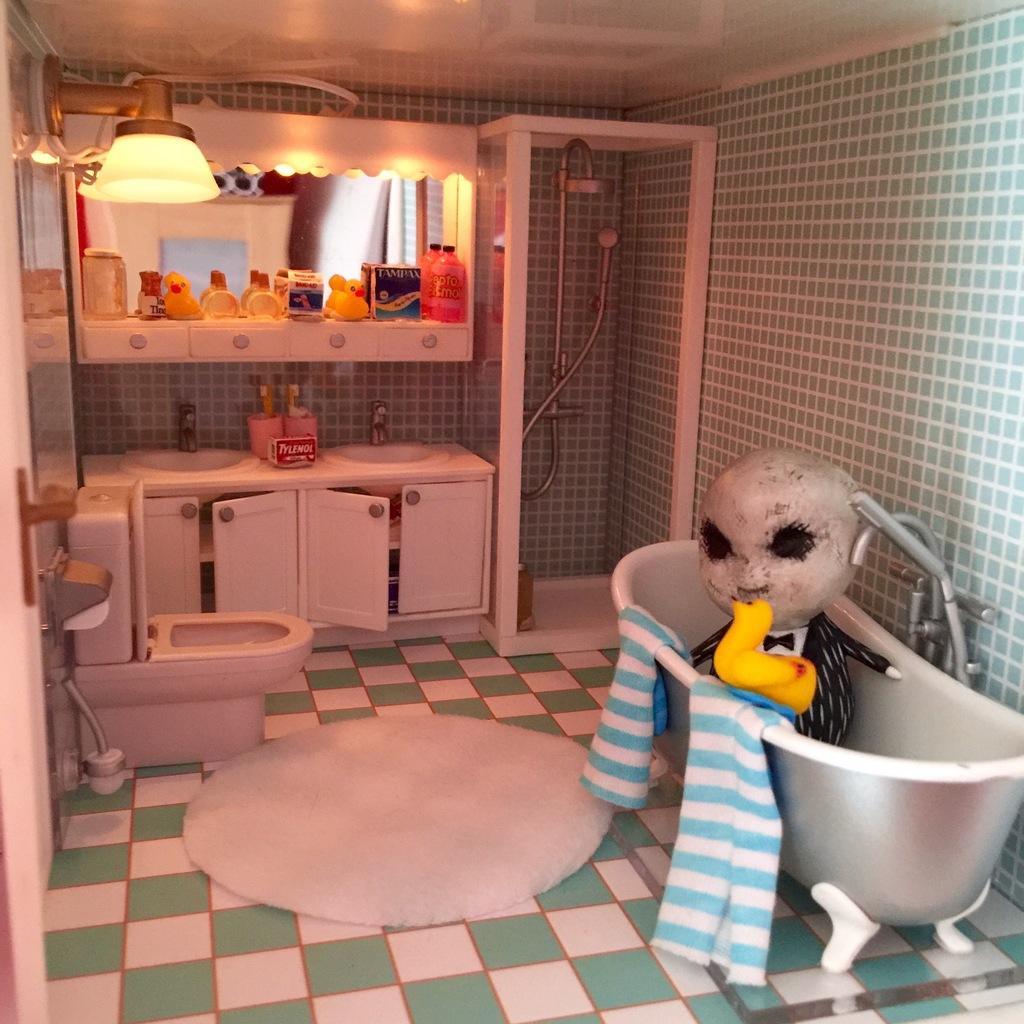Can you describe this image briefly? In this image there is a toy washroom. At the bottom of the image there is a floor. In this image there are many miniature things. In the background there is a wall and there are a few cupboards with many things and there is a mirror and there are a few things on the shelf. On the left side of the image there is a door and there is a toilet seat. At the top of the image there is a ceiling and a lamp. On the right side of the image there is a bathtub with a towel and there is a toy man in the bathtub. 